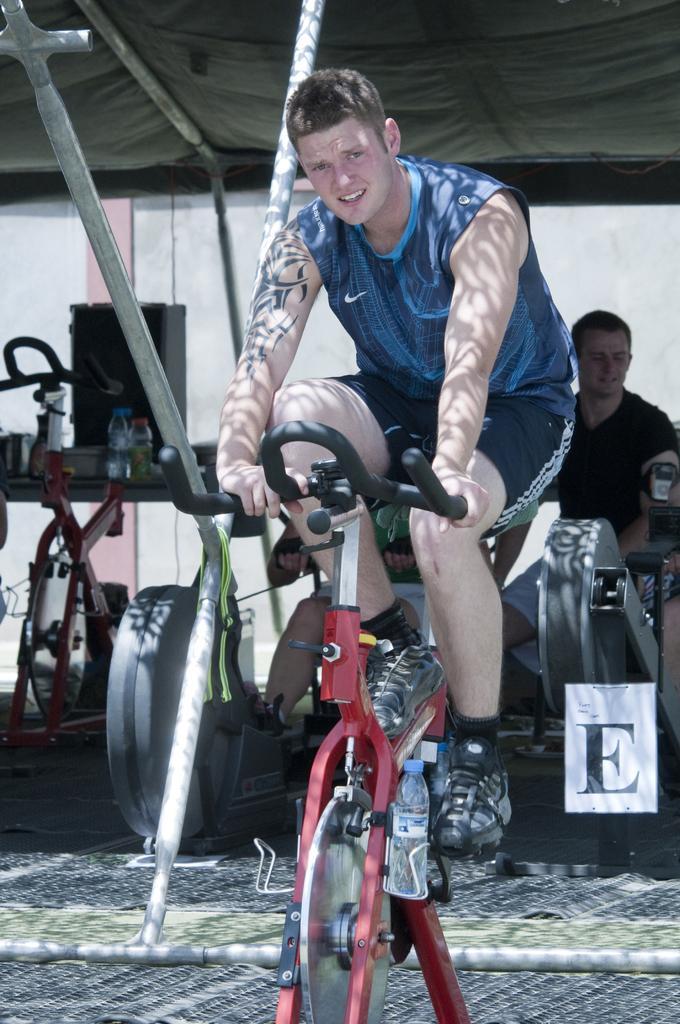Describe this image in one or two sentences. There is a man in this image who is wearing blue t-shirt and cycling, and there is a water bottle attached to that cycle and at the backside of the image one guy who is doing gym and at the left side of the image there is a another cycle and three water bottles,at the top of the image there is a tent 